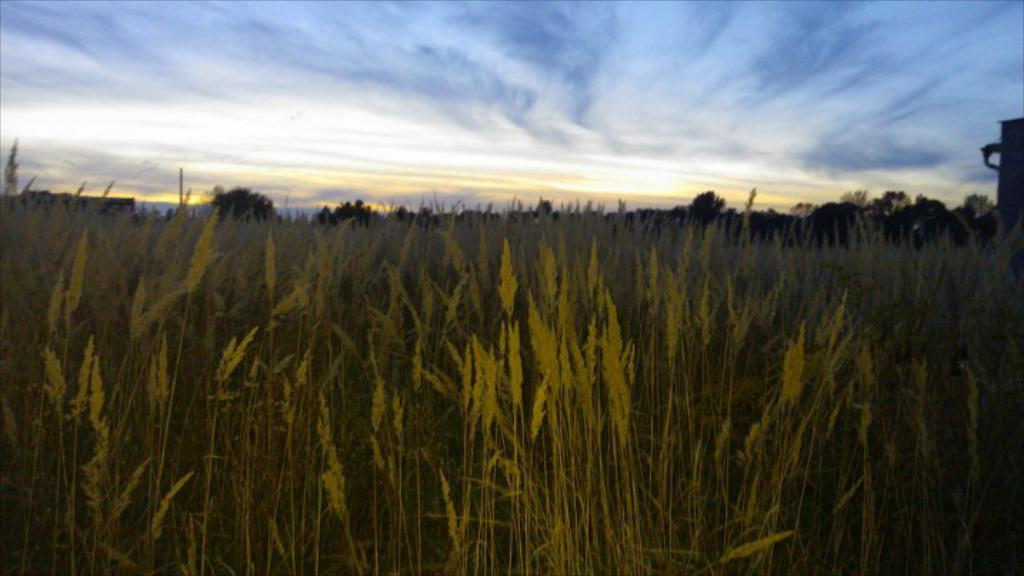What type of landscape is shown in the image? There is a field in the image. What can be seen in the distance behind the field? There are trees in the background of the image. What else is visible in the background of the image? The sky is visible in the background of the image. What type of pet can be seen playing in the field in the image? There is no pet present in the image; it only shows a field with trees and the sky in the background. 